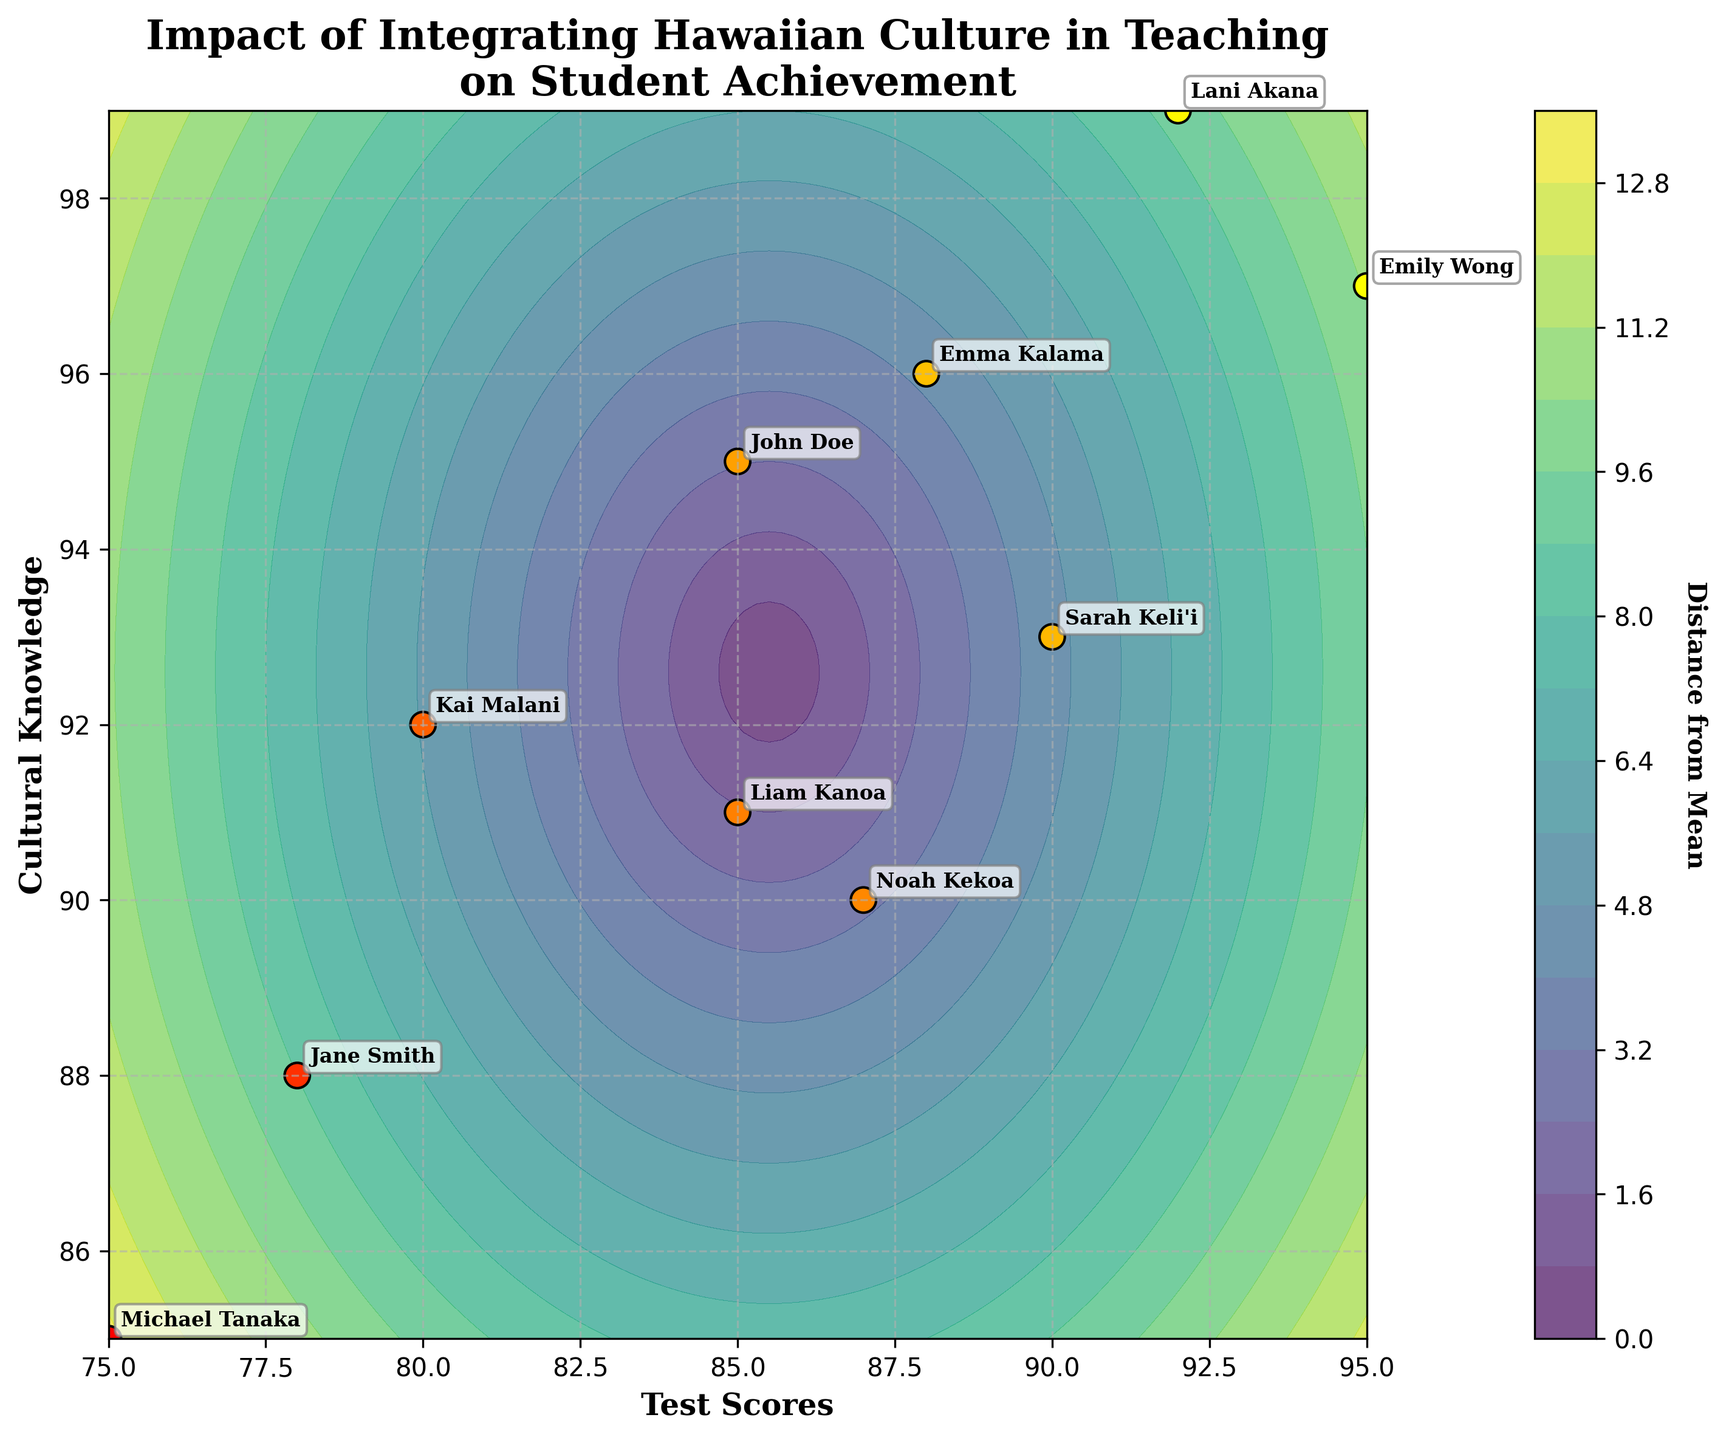What is the title of the plot? The title is located at the top of the plot. Upon observation, you can see the text "Impact of Integrating Hawaiian Culture in Teaching on Student Achievement".
Answer: Impact of Integrating Hawaiian Culture in Teaching on Student Achievement How many students' data points are represented in the scatter plot? To determine the number of data points, count the annotated student names in the scatter plot. There are 10 unique data points (students).
Answer: 10 Which student has the highest test score? Locate the scatter point with the highest value on the x-axis (Test Scores). The annotated name for the highest x-value (95) is Emily Wong.
Answer: Emily Wong What are the test scores and cultural knowledge values for Kai Malani? Find the annotation for Kai Malani. From the plot, Kai's data point has a Test Score of 80 and Cultural Knowledge of 92, indicated by the coordinates of the scatter point.
Answer: 80, 92 Who has the least cultural knowledge among the students? Look for the scatter point with the lowest value on the y-axis (Cultural Knowledge). The annotated name for the lowest y-value (85) is Michael Tanaka.
Answer: Michael Tanaka What is the average test score of the students? Sum up all the test scores (85 + 78 + 92 + 80 + 75 + 95 + 87 + 90 + 85 + 88) and divide by the number of students (10). This gives (855 / 10).
Answer: 85.5 Which student has a higher test score, Sarah Keli'i or Noah Kekoa? Find the annotations for both Sarah Keli'i and Noah Kekoa. Sarah has a Test Score of 90, while Noah has a Test Score of 87.
Answer: Sarah Keli'i What region represents equal distance from the mean Test Scores and Cultural Knowledge? Locate the contour line in the plot that centers the mean test scores and cultural knowledge grid intersection. This evenly spaced region indicates equal distance.
Answer: Central contour line Do students with higher cultural knowledge tend to have higher test scores according to the plot? Observe the trend in the scatter plot. Scatter points are generally distributed from the bottom-left (lower values) to the top-right (higher values), indicating a positive correlation.
Answer: Yes 